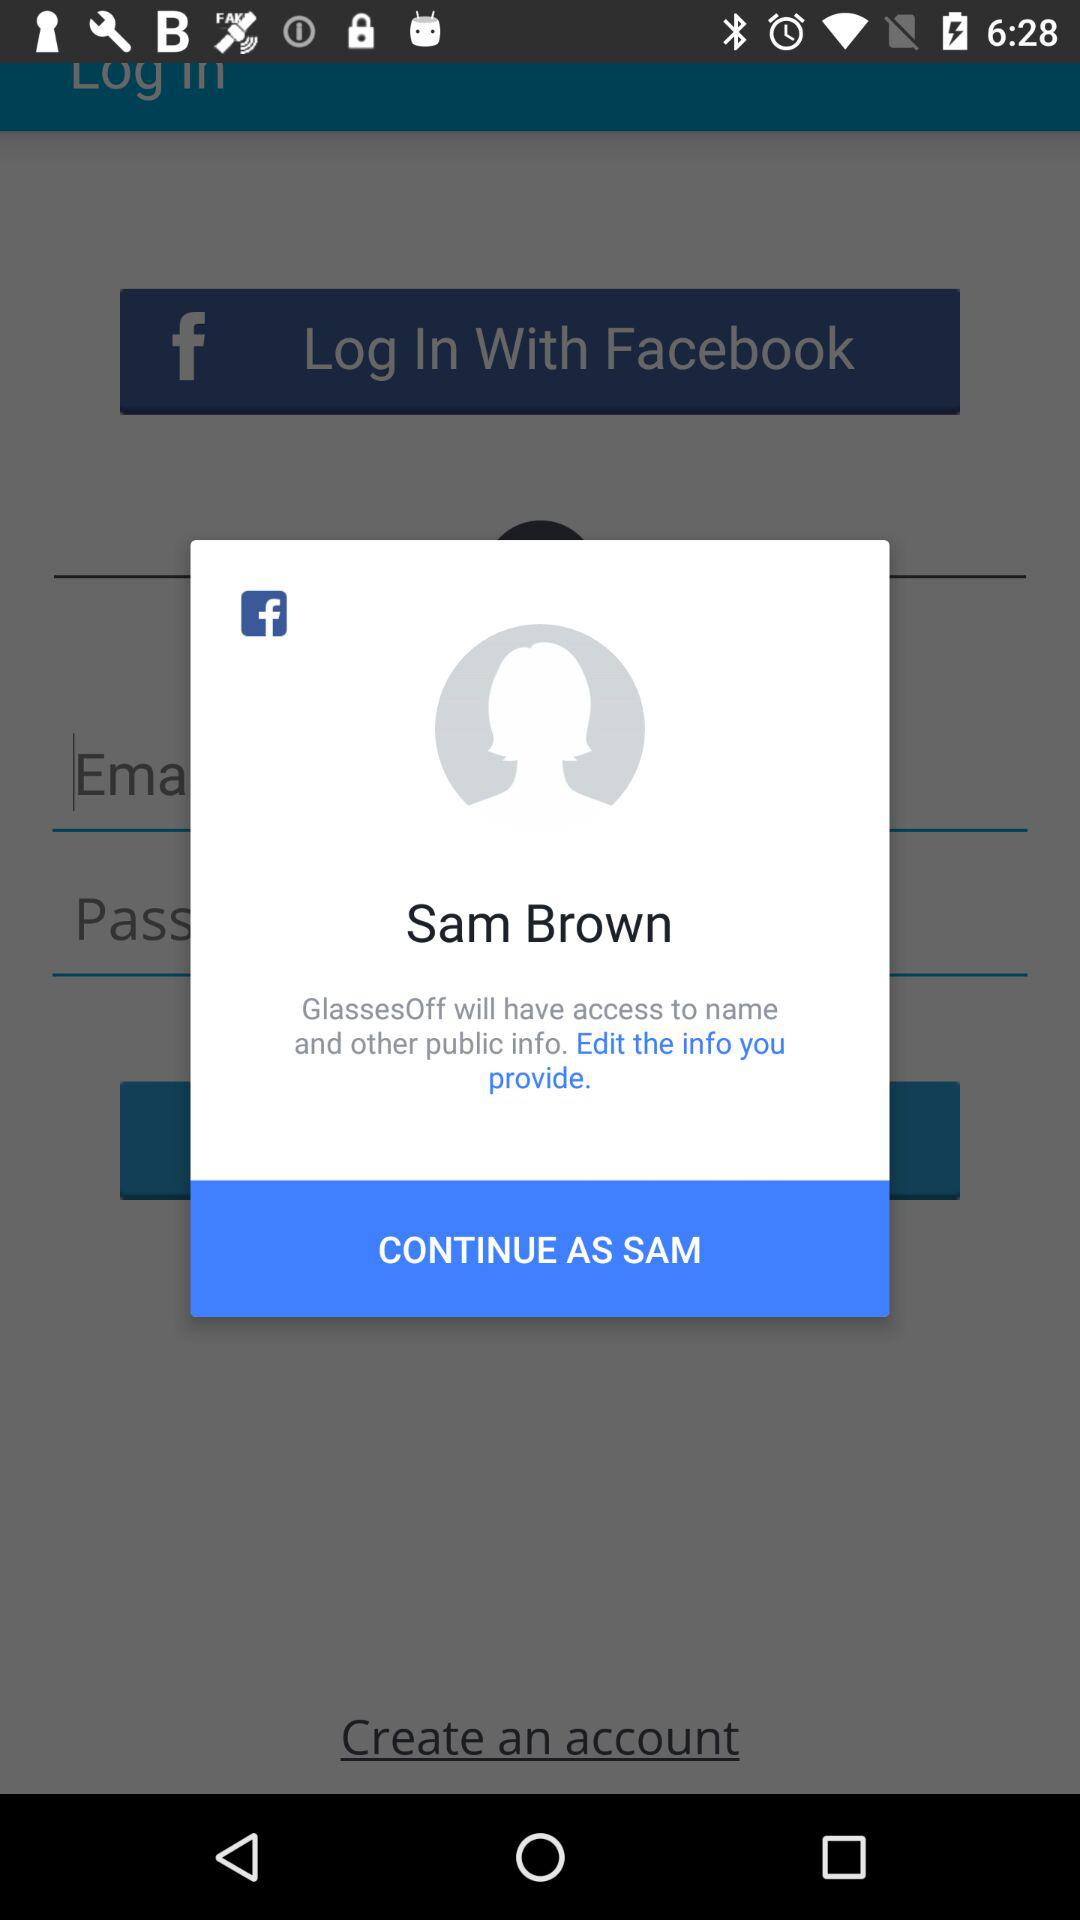What is the user name to continue on the login page? The user name is Sam Brown. 